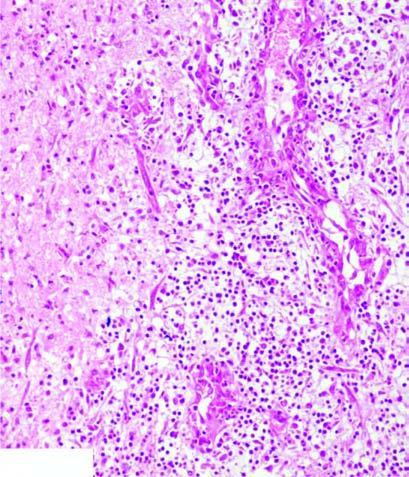does the surrounding zone show granulation tissue and gliosis?
Answer the question using a single word or phrase. Yes 